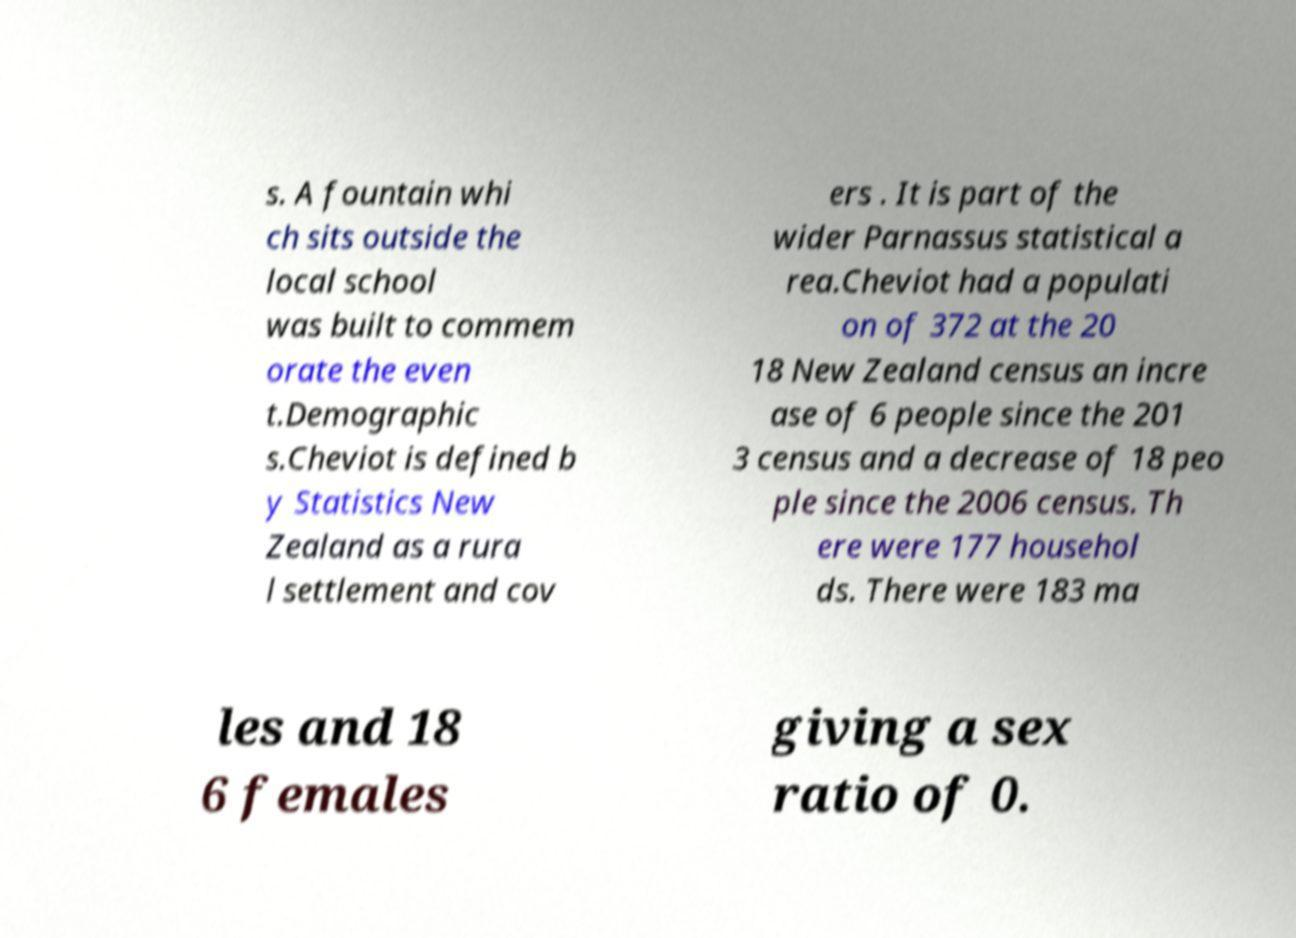Could you assist in decoding the text presented in this image and type it out clearly? s. A fountain whi ch sits outside the local school was built to commem orate the even t.Demographic s.Cheviot is defined b y Statistics New Zealand as a rura l settlement and cov ers . It is part of the wider Parnassus statistical a rea.Cheviot had a populati on of 372 at the 20 18 New Zealand census an incre ase of 6 people since the 201 3 census and a decrease of 18 peo ple since the 2006 census. Th ere were 177 househol ds. There were 183 ma les and 18 6 females giving a sex ratio of 0. 